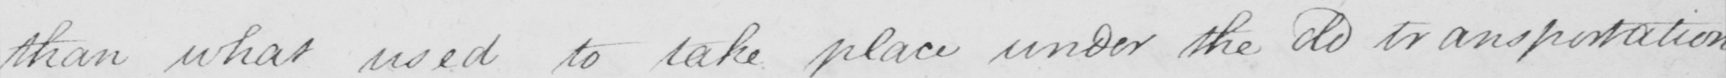Transcribe the text shown in this historical manuscript line. than what used to take place under the do transportation 